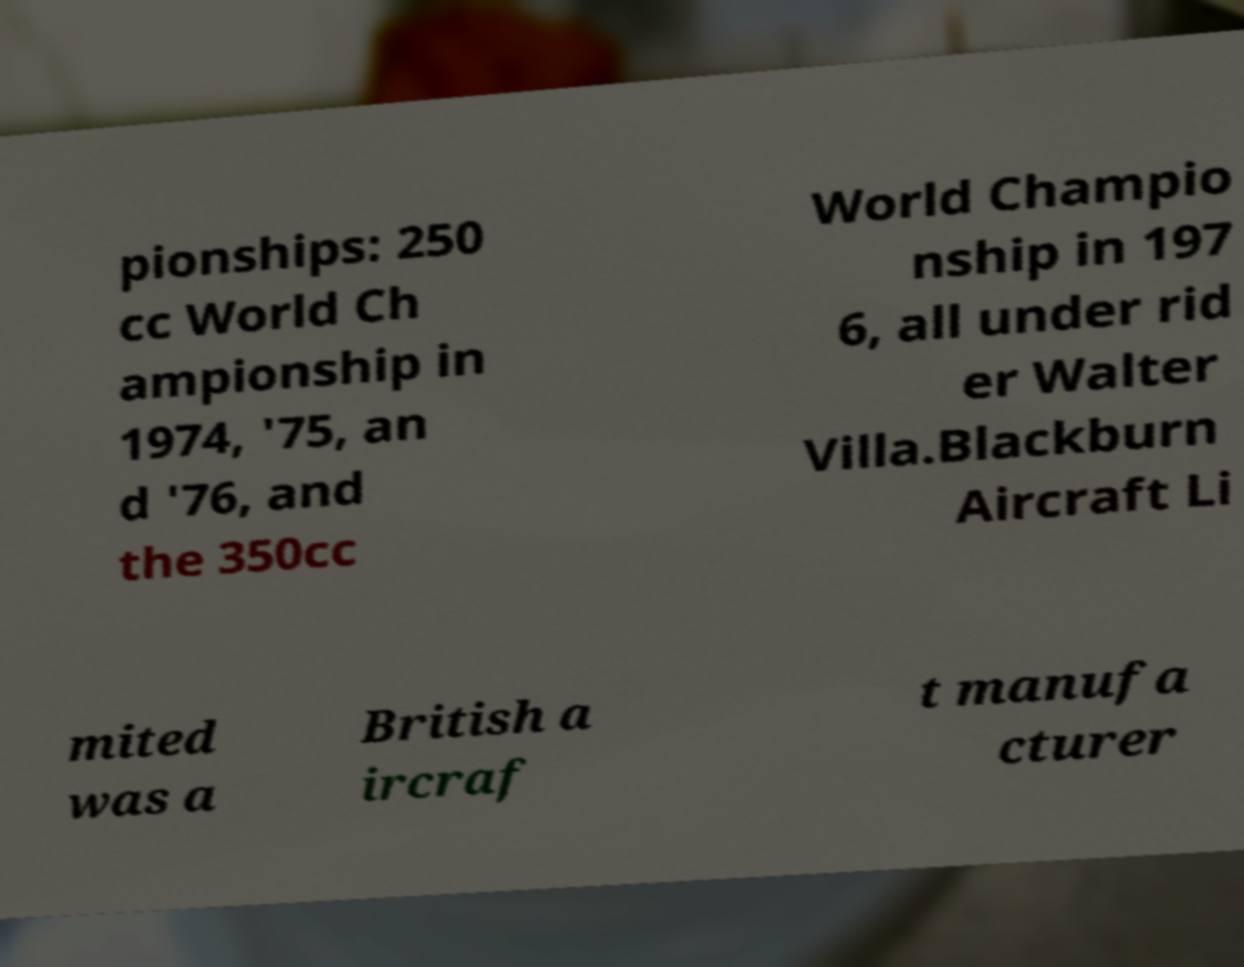I need the written content from this picture converted into text. Can you do that? pionships: 250 cc World Ch ampionship in 1974, '75, an d '76, and the 350cc World Champio nship in 197 6, all under rid er Walter Villa.Blackburn Aircraft Li mited was a British a ircraf t manufa cturer 